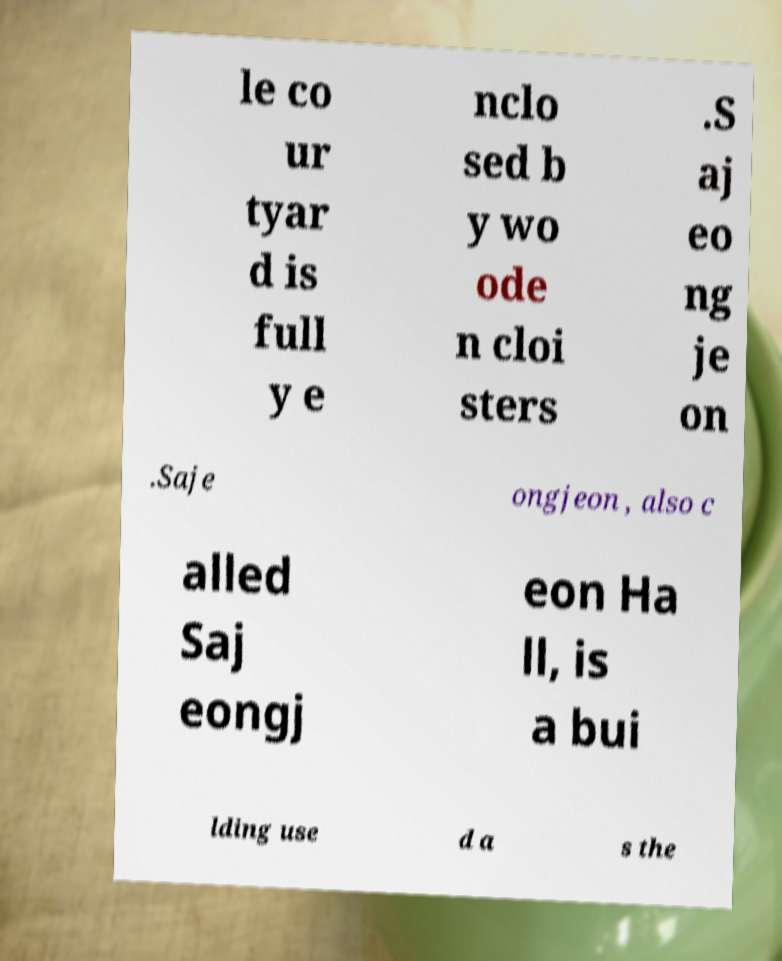Can you read and provide the text displayed in the image?This photo seems to have some interesting text. Can you extract and type it out for me? le co ur tyar d is full y e nclo sed b y wo ode n cloi sters .S aj eo ng je on .Saje ongjeon , also c alled Saj eongj eon Ha ll, is a bui lding use d a s the 